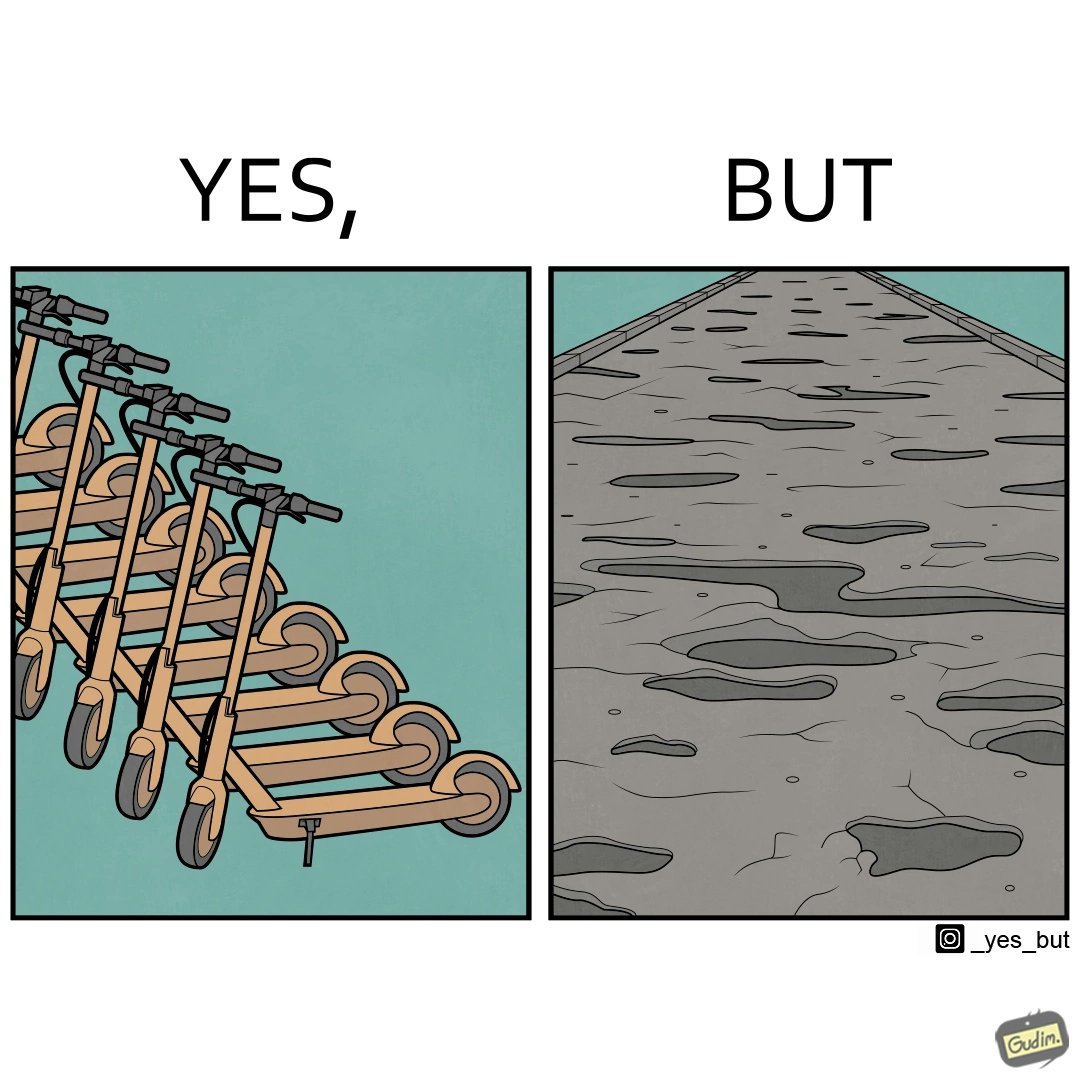What is shown in the left half versus the right half of this image? In the left part of the image: many skateboard scooters parked together In the right part of the image: a straight road with many potholes 